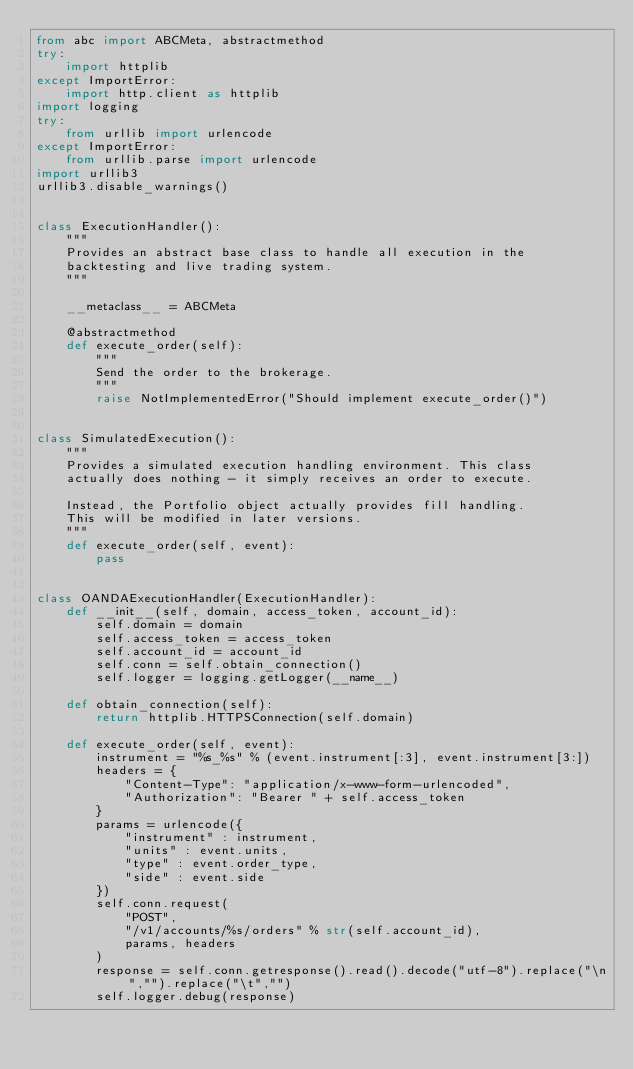<code> <loc_0><loc_0><loc_500><loc_500><_Python_>from abc import ABCMeta, abstractmethod
try:
    import httplib
except ImportError:
    import http.client as httplib
import logging
try:
    from urllib import urlencode
except ImportError:
    from urllib.parse import urlencode
import urllib3
urllib3.disable_warnings()


class ExecutionHandler():
    """
    Provides an abstract base class to handle all execution in the
    backtesting and live trading system.
    """

    __metaclass__ = ABCMeta

    @abstractmethod
    def execute_order(self):
        """
        Send the order to the brokerage.
        """
        raise NotImplementedError("Should implement execute_order()")


class SimulatedExecution():
    """
    Provides a simulated execution handling environment. This class
    actually does nothing - it simply receives an order to execute.

    Instead, the Portfolio object actually provides fill handling.
    This will be modified in later versions.
    """
    def execute_order(self, event):
        pass


class OANDAExecutionHandler(ExecutionHandler):
    def __init__(self, domain, access_token, account_id):
        self.domain = domain
        self.access_token = access_token
        self.account_id = account_id
        self.conn = self.obtain_connection()
        self.logger = logging.getLogger(__name__)

    def obtain_connection(self):
        return httplib.HTTPSConnection(self.domain)

    def execute_order(self, event):
        instrument = "%s_%s" % (event.instrument[:3], event.instrument[3:])
        headers = {
            "Content-Type": "application/x-www-form-urlencoded",
            "Authorization": "Bearer " + self.access_token
        }
        params = urlencode({
            "instrument" : instrument,
            "units" : event.units,
            "type" : event.order_type,
            "side" : event.side
        })
        self.conn.request(
            "POST",
            "/v1/accounts/%s/orders" % str(self.account_id),
            params, headers
        )
        response = self.conn.getresponse().read().decode("utf-8").replace("\n","").replace("\t","")
        self.logger.debug(response)
</code> 